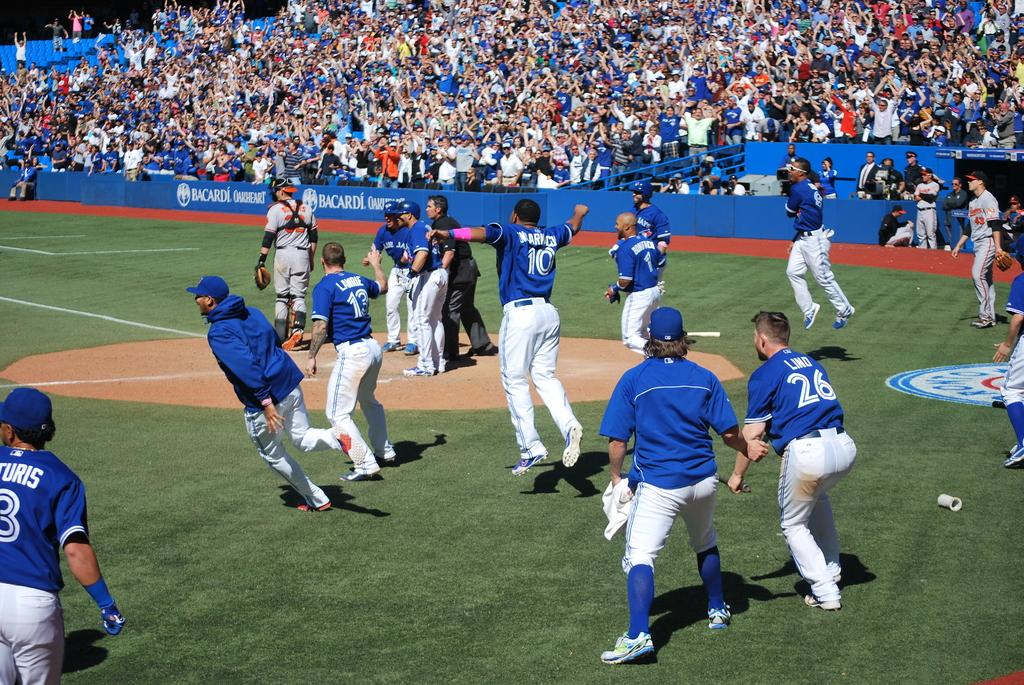<image>
Write a terse but informative summary of the picture. Toronto Blue Jays is the team name shown on these jerseys. 